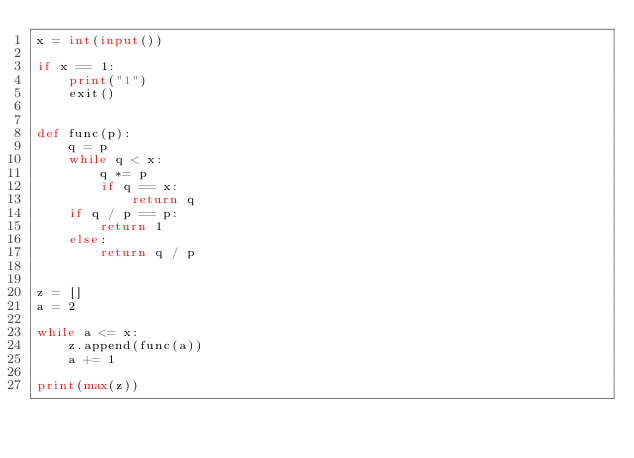<code> <loc_0><loc_0><loc_500><loc_500><_Python_>x = int(input())

if x == 1:
    print("1")
    exit()


def func(p):
    q = p
    while q < x:
        q *= p
        if q == x:
            return q          
    if q / p == p:
        return 1
    else:
        return q / p


z = []
a = 2

while a <= x:
    z.append(func(a))
    a += 1

print(max(z))
</code> 